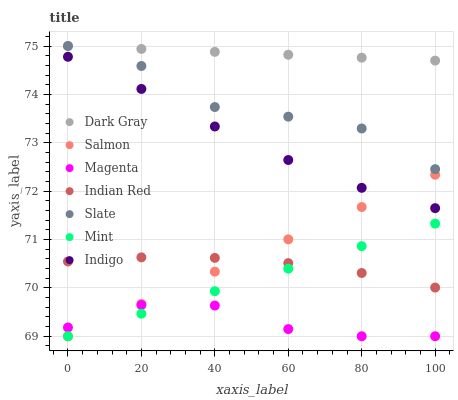Does Magenta have the minimum area under the curve?
Answer yes or no. Yes. Does Dark Gray have the maximum area under the curve?
Answer yes or no. Yes. Does Slate have the minimum area under the curve?
Answer yes or no. No. Does Slate have the maximum area under the curve?
Answer yes or no. No. Is Mint the smoothest?
Answer yes or no. Yes. Is Slate the roughest?
Answer yes or no. Yes. Is Salmon the smoothest?
Answer yes or no. No. Is Salmon the roughest?
Answer yes or no. No. Does Salmon have the lowest value?
Answer yes or no. Yes. Does Slate have the lowest value?
Answer yes or no. No. Does Dark Gray have the highest value?
Answer yes or no. Yes. Does Salmon have the highest value?
Answer yes or no. No. Is Magenta less than Indian Red?
Answer yes or no. Yes. Is Slate greater than Salmon?
Answer yes or no. Yes. Does Mint intersect Magenta?
Answer yes or no. Yes. Is Mint less than Magenta?
Answer yes or no. No. Is Mint greater than Magenta?
Answer yes or no. No. Does Magenta intersect Indian Red?
Answer yes or no. No. 